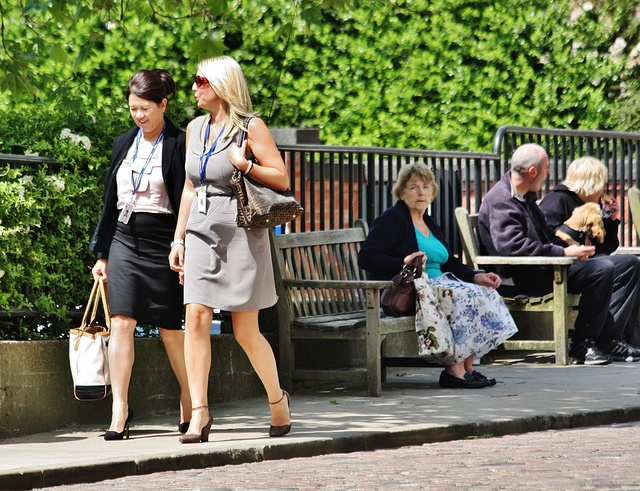Describe the objects in this image and their specific colors. I can see people in olive, lightgray, tan, and darkgray tones, people in olive, black, white, and gray tones, people in olive, black, darkgray, lightgray, and gray tones, bench in olive, black, gray, darkgray, and darkgreen tones, and people in olive, black, gray, darkgray, and lightgray tones in this image. 